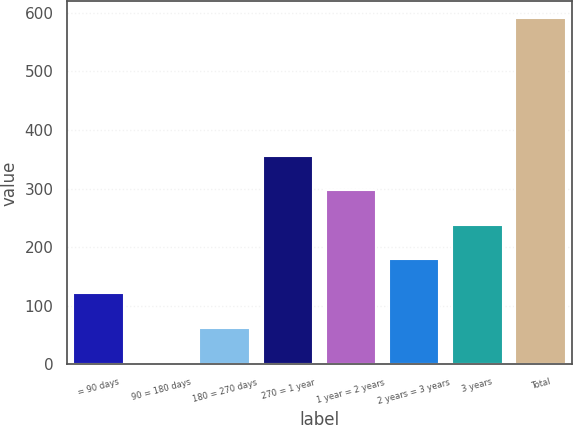Convert chart. <chart><loc_0><loc_0><loc_500><loc_500><bar_chart><fcel>= 90 days<fcel>90 = 180 days<fcel>180 = 270 days<fcel>270 = 1 year<fcel>1 year = 2 years<fcel>2 years = 3 years<fcel>3 years<fcel>Total<nl><fcel>121.4<fcel>4.2<fcel>62.8<fcel>355.8<fcel>297.2<fcel>180<fcel>238.6<fcel>590.2<nl></chart> 